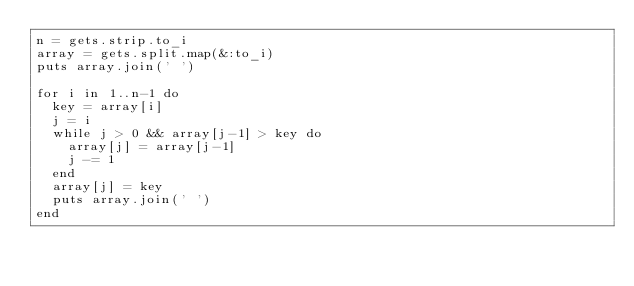<code> <loc_0><loc_0><loc_500><loc_500><_Ruby_>n = gets.strip.to_i
array = gets.split.map(&:to_i)
puts array.join(' ')

for i in 1..n-1 do
  key = array[i]
  j = i
  while j > 0 && array[j-1] > key do
    array[j] = array[j-1]
    j -= 1
  end
  array[j] = key
  puts array.join(' ')
end</code> 